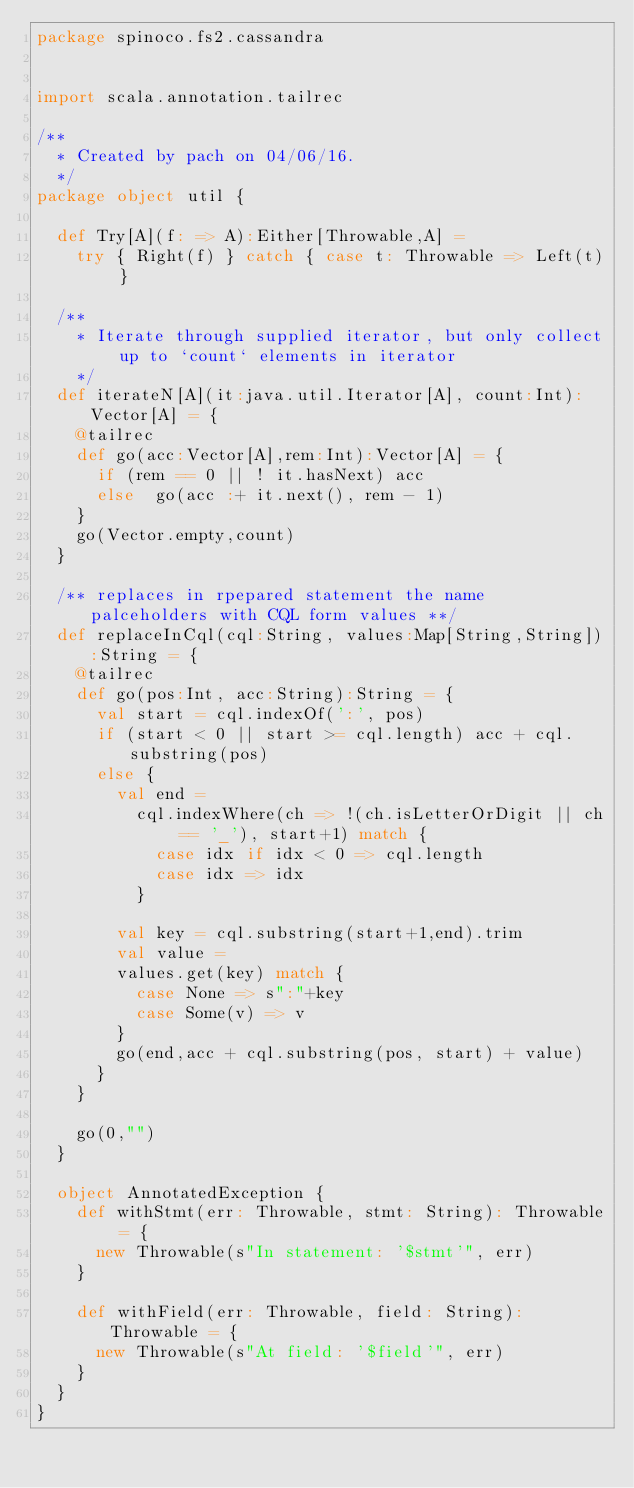Convert code to text. <code><loc_0><loc_0><loc_500><loc_500><_Scala_>package spinoco.fs2.cassandra


import scala.annotation.tailrec

/**
  * Created by pach on 04/06/16.
  */
package object util {

  def Try[A](f: => A):Either[Throwable,A] =
    try { Right(f) } catch { case t: Throwable => Left(t) }

  /**
    * Iterate through supplied iterator, but only collect up to `count` elements in iterator
    */
  def iterateN[A](it:java.util.Iterator[A], count:Int):Vector[A] = {
    @tailrec
    def go(acc:Vector[A],rem:Int):Vector[A] = {
      if (rem == 0 || ! it.hasNext) acc
      else  go(acc :+ it.next(), rem - 1)
    }
    go(Vector.empty,count)
  }

  /** replaces in rpepared statement the name palceholders with CQL form values **/
  def replaceInCql(cql:String, values:Map[String,String]):String = {
    @tailrec
    def go(pos:Int, acc:String):String = {
      val start = cql.indexOf(':', pos)
      if (start < 0 || start >= cql.length) acc + cql.substring(pos)
      else {
        val end =
          cql.indexWhere(ch => !(ch.isLetterOrDigit || ch == '_'), start+1) match {
            case idx if idx < 0 => cql.length
            case idx => idx
          }

        val key = cql.substring(start+1,end).trim
        val value =
        values.get(key) match {
          case None => s":"+key
          case Some(v) => v
        }
        go(end,acc + cql.substring(pos, start) + value)
      }
    }

    go(0,"")
  }

  object AnnotatedException {
    def withStmt(err: Throwable, stmt: String): Throwable = {
      new Throwable(s"In statement: '$stmt'", err)
    }

    def withField(err: Throwable, field: String): Throwable = {
      new Throwable(s"At field: '$field'", err)
    }
  }
}
</code> 